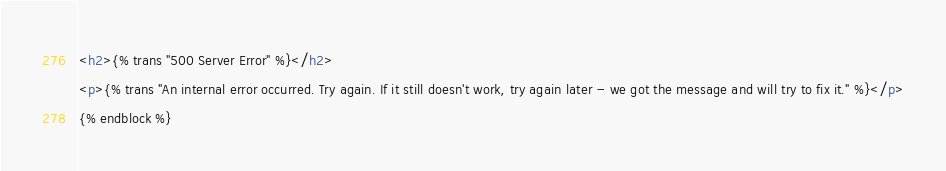<code> <loc_0><loc_0><loc_500><loc_500><_HTML_><h2>{% trans "500 Server Error" %}</h2>
<p>{% trans "An internal error occurred. Try again. If it still doesn't work, try again later - we got the message and will try to fix it." %}</p>
{% endblock %}</code> 